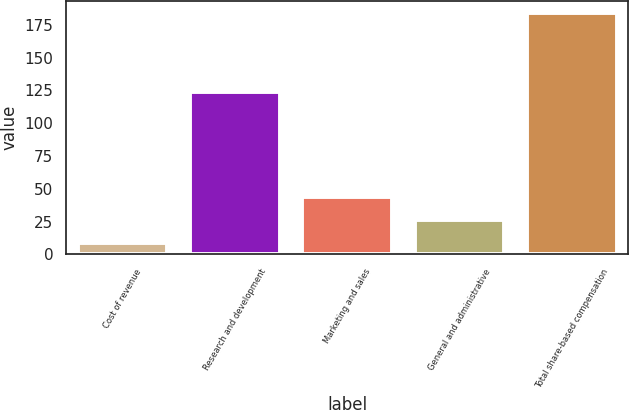Convert chart to OTSL. <chart><loc_0><loc_0><loc_500><loc_500><bar_chart><fcel>Cost of revenue<fcel>Research and development<fcel>Marketing and sales<fcel>General and administrative<fcel>Total share-based compensation<nl><fcel>9<fcel>124<fcel>44<fcel>26.5<fcel>184<nl></chart> 